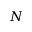<formula> <loc_0><loc_0><loc_500><loc_500>N</formula> 